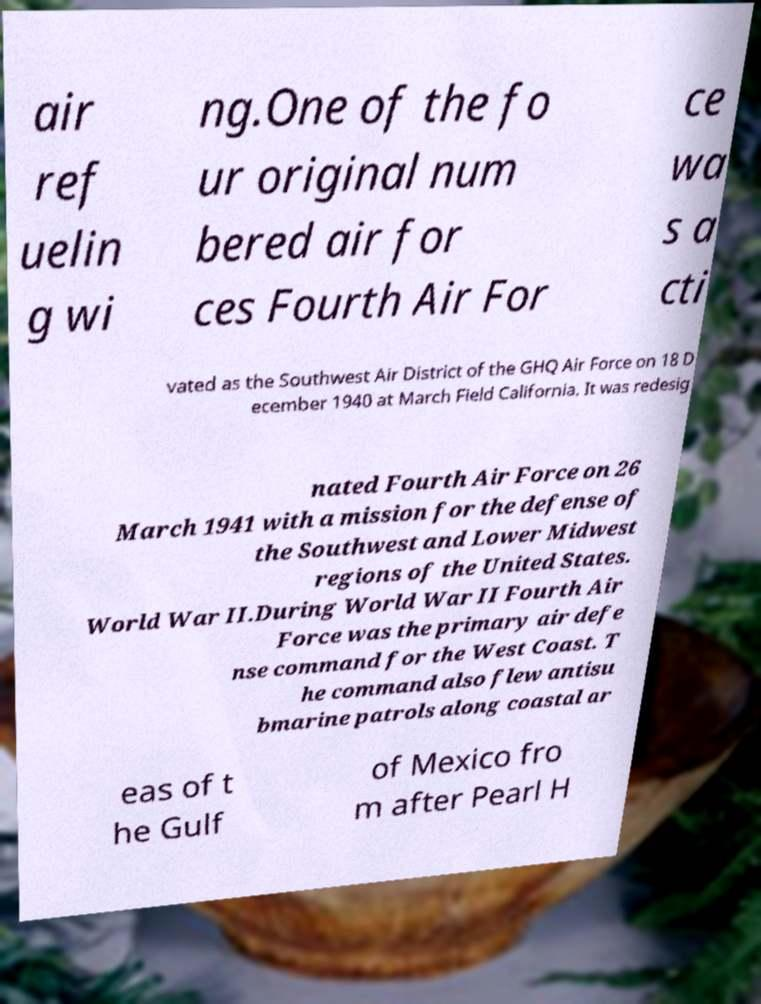Could you extract and type out the text from this image? air ref uelin g wi ng.One of the fo ur original num bered air for ces Fourth Air For ce wa s a cti vated as the Southwest Air District of the GHQ Air Force on 18 D ecember 1940 at March Field California. It was redesig nated Fourth Air Force on 26 March 1941 with a mission for the defense of the Southwest and Lower Midwest regions of the United States. World War II.During World War II Fourth Air Force was the primary air defe nse command for the West Coast. T he command also flew antisu bmarine patrols along coastal ar eas of t he Gulf of Mexico fro m after Pearl H 